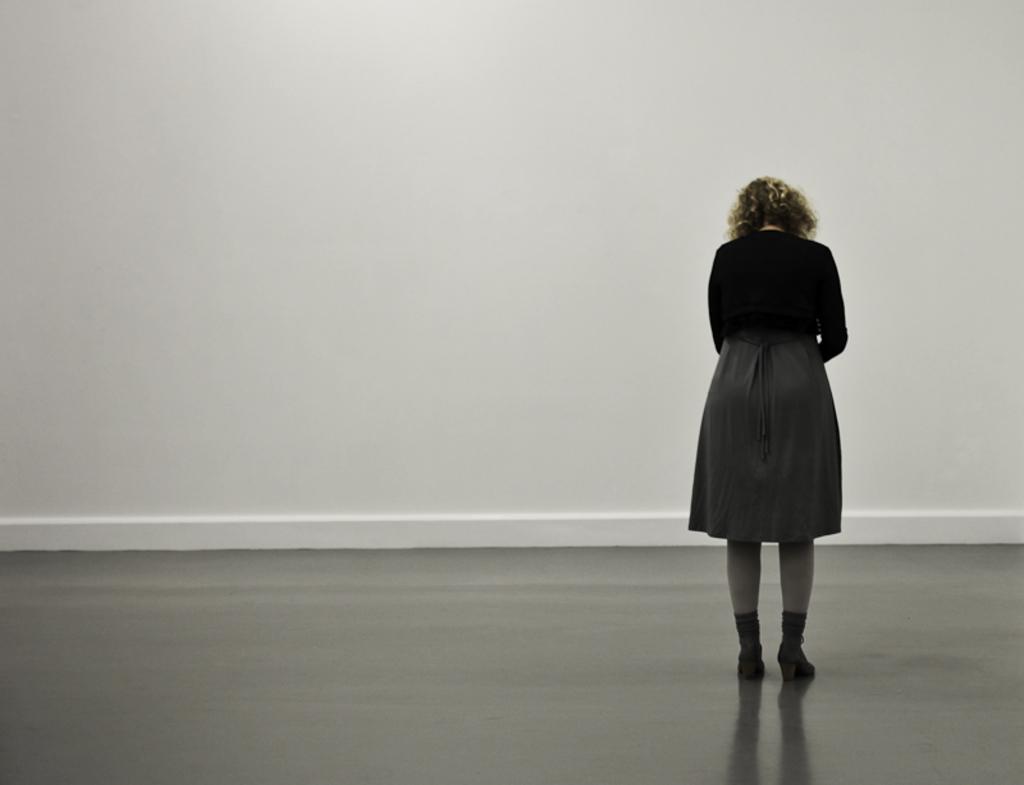In one or two sentences, can you explain what this image depicts? In the picture I can see a woman is standing on the floor. In the background I can see a white color wall. 